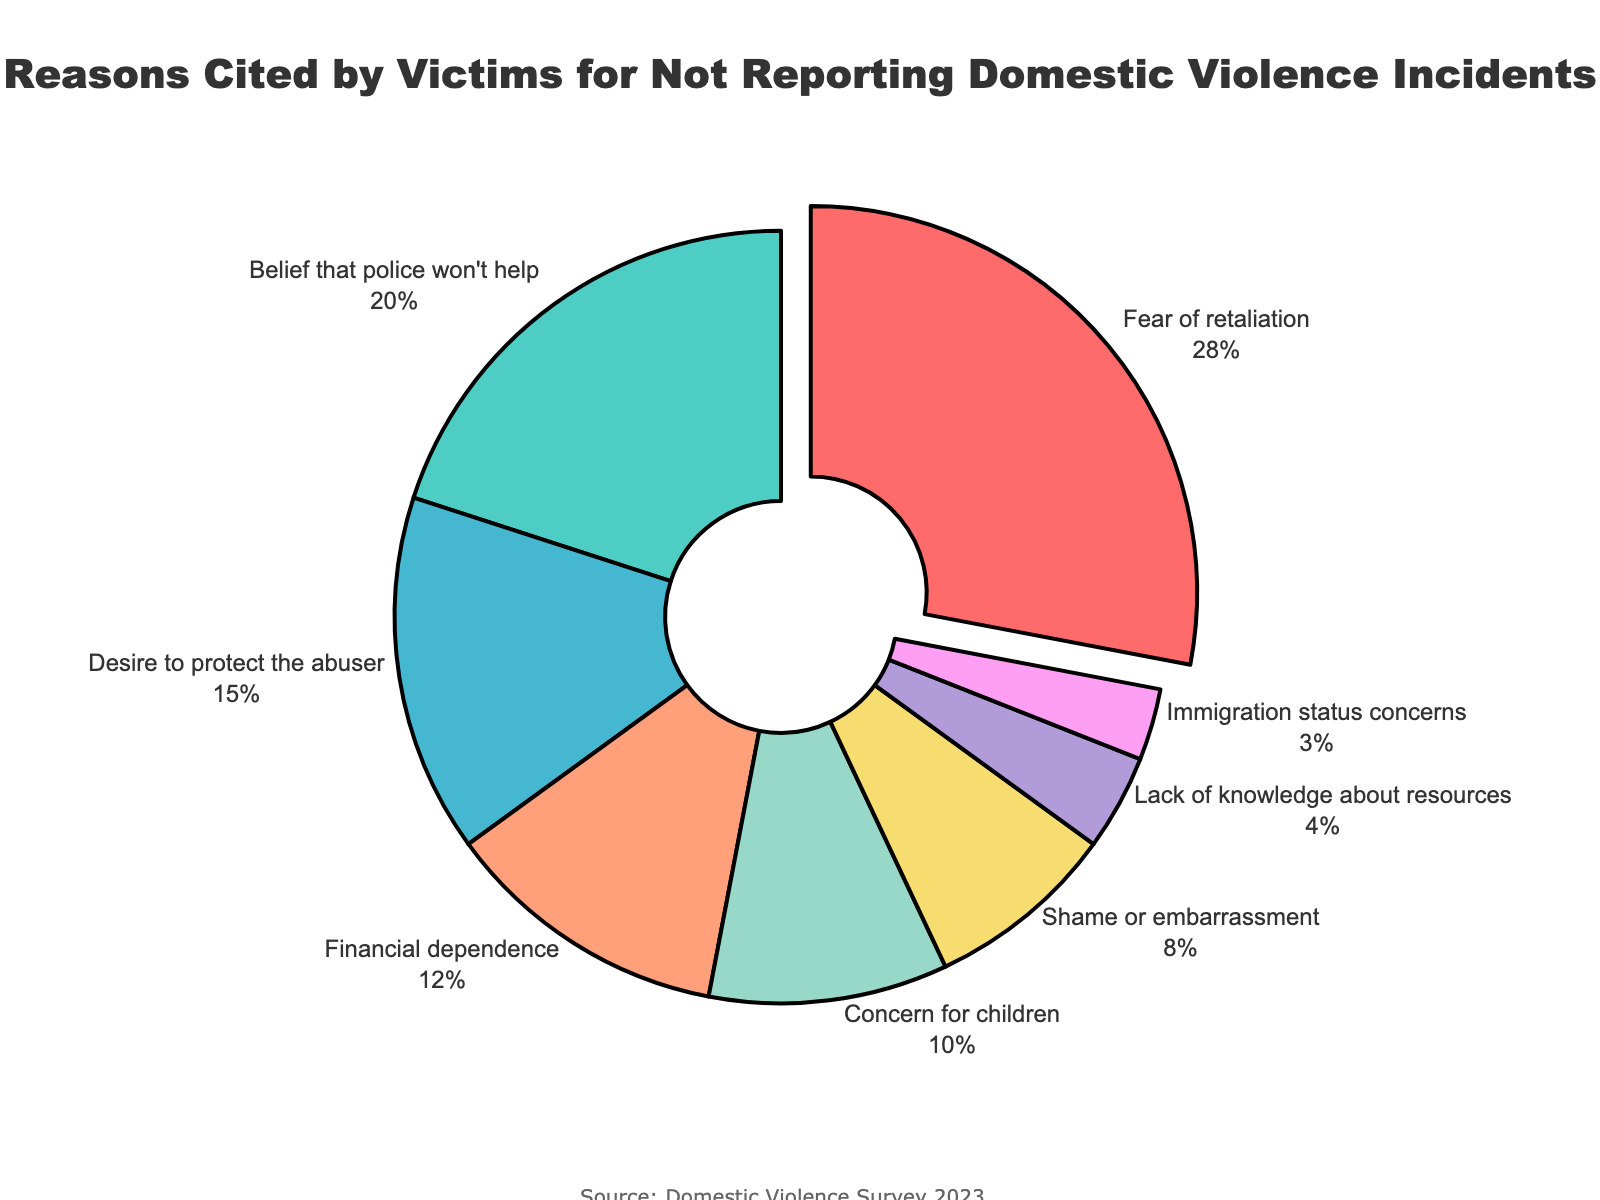What reason is cited by the highest percentage of victims? Look at the pie chart and identify the segment with the largest percentage. This segment is labeled "Fear of retaliation" with 28%.
Answer: Fear of retaliation Which two reasons combined account for nearly half of the responses? Calculate the sum of the percentages of "Fear of retaliation" (28%) and "Belief that police won't help" (20%) to determine if they add up to nearly 50%.
Answer: Fear of retaliation and Belief that police won't help How much greater is the percentage of victims citing fear of retaliation compared to those citing shame or embarrassment? Subtract the percentage of "Shame or embarrassment" (8%) from the percentage of "Fear of retaliation" (28%). The difference is 28% - 8% = 20%.
Answer: 20% What is the third most cited reason for not reporting domestic violence incidents, and what is its percentage? Identify the third largest segment in the pie chart. The third most cited reason is "Desire to protect the abuser" with 15%.
Answer: Desire to protect the abuser, 15% How does the percentage of victims citing financial dependence compare to those concerned about their immigration status? Compare the percentages of the reasons "Financial dependence" (12%) and "Immigration status concerns" (3%). Financial dependence (12%) is greater than immigration status concerns (3%).
Answer: Financial dependence is greater Which reason accounts for a smaller percentage: lack of knowledge about resources or concern for children? Compare the percentages of "Lack of knowledge about resources" (4%) and "Concern for children" (10%). Lack of knowledge about resources (4%) is smaller than concern for children (10%).
Answer: Lack of knowledge about resources What is the total percentage of victims who cited reasons related to family (protecting the abuser and concern for children)? Add the percentages of "Desire to protect the abuser" (15%) and "Concern for children" (10%). The total is 15% + 10% = 25%.
Answer: 25% Which colored segment represents financial dependence, and what is its percentage? Identify the color associated with the "Financial dependence" segment in the pie chart. It is colored in a light orange shade (12%).
Answer: Light orange, 12% What percentage of victims cited immigration status concerns as a reason for not reporting domestic violence incidents? Find the segment labeled "Immigration status concerns" and note its percentage, which is 3%.
Answer: 3% Which comes closer in percentage, shame or embarrassment or lack of knowledge about resources, to financial dependence? Compare the percentages of "Shame or embarrassment" (8%) and "Lack of knowledge about resources" (4%) to "Financial dependence" (12%). "Shame or embarrassment" (8%) is closer to 12% than "Lack of knowledge about resources" (4%).
Answer: Shame or embarrassment 